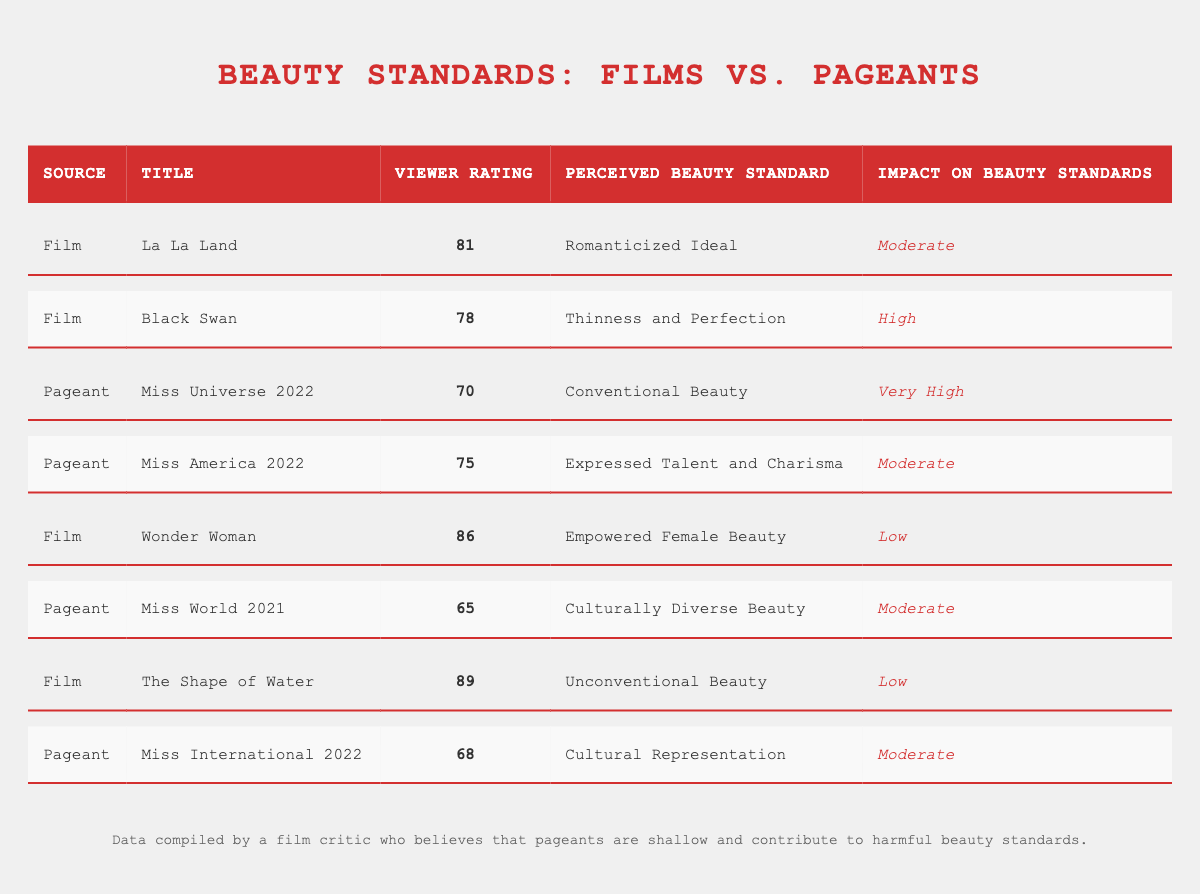What is the Viewer Rating of "Miss Universe 2022"? The table lists the Viewer Rating for "Miss Universe 2022" under the ViewerPerception data, which shows a value of 70.
Answer: 70 Which Film has the highest Viewer Rating? By comparing the Viewer Ratings of all films listed, "The Shape of Water" has the highest rating at 89.
Answer: The Shape of Water What is the average Viewer Rating of the Pageants? The Viewer Ratings for the pageants are 70, 75, 65, and 68. To find the average, sum these values (70 + 75 + 65 + 68 = 278) and divide by the number of pageants (4), resulting in 278/4 = 69.5.
Answer: 69.5 Does "Wonder Woman" have a high impact on beauty standards? Looking at the Impact on Beauty Standards column, "Wonder Woman" is listed with a low impact.
Answer: No Which Perceived Beauty Standard has the highest impact according to the table? From the Impact on Beauty Standards column, "Miss Universe 2022" has the highest rating categorized as "Very High" which correlates with conventional beauty standards.
Answer: Conventional Beauty How many films are rated above 80? The films and their Viewer Ratings are La La Land (81), Black Swan (78), Wonder Woman (86), and The Shape of Water (89). Only La La Land, Wonder Woman, and The Shape of Water have ratings above 80. Therefore, there are three.
Answer: 3 Among the films, which has the perceived beauty standard of "Thinness and Perfection"? The table lists "Black Swan" under films as having the perceived beauty standard of "Thinness and Perfection".
Answer: Black Swan Are most of the Viewer Ratings for Pageants higher than those for Films? Comparing the Viewer Ratings, the average for Pageants is (70 + 75 + 65 + 68 = 278) which is 69.5 and for Films (81 + 78 + 86 + 89 = 334) which is 83.5, thus films have a higher average.
Answer: No What is the Perceived Beauty Standard for "The Shape of Water"? The table lists the Perceived Beauty Standard for "The Shape of Water" as "Unconventional Beauty".
Answer: Unconventional Beauty 